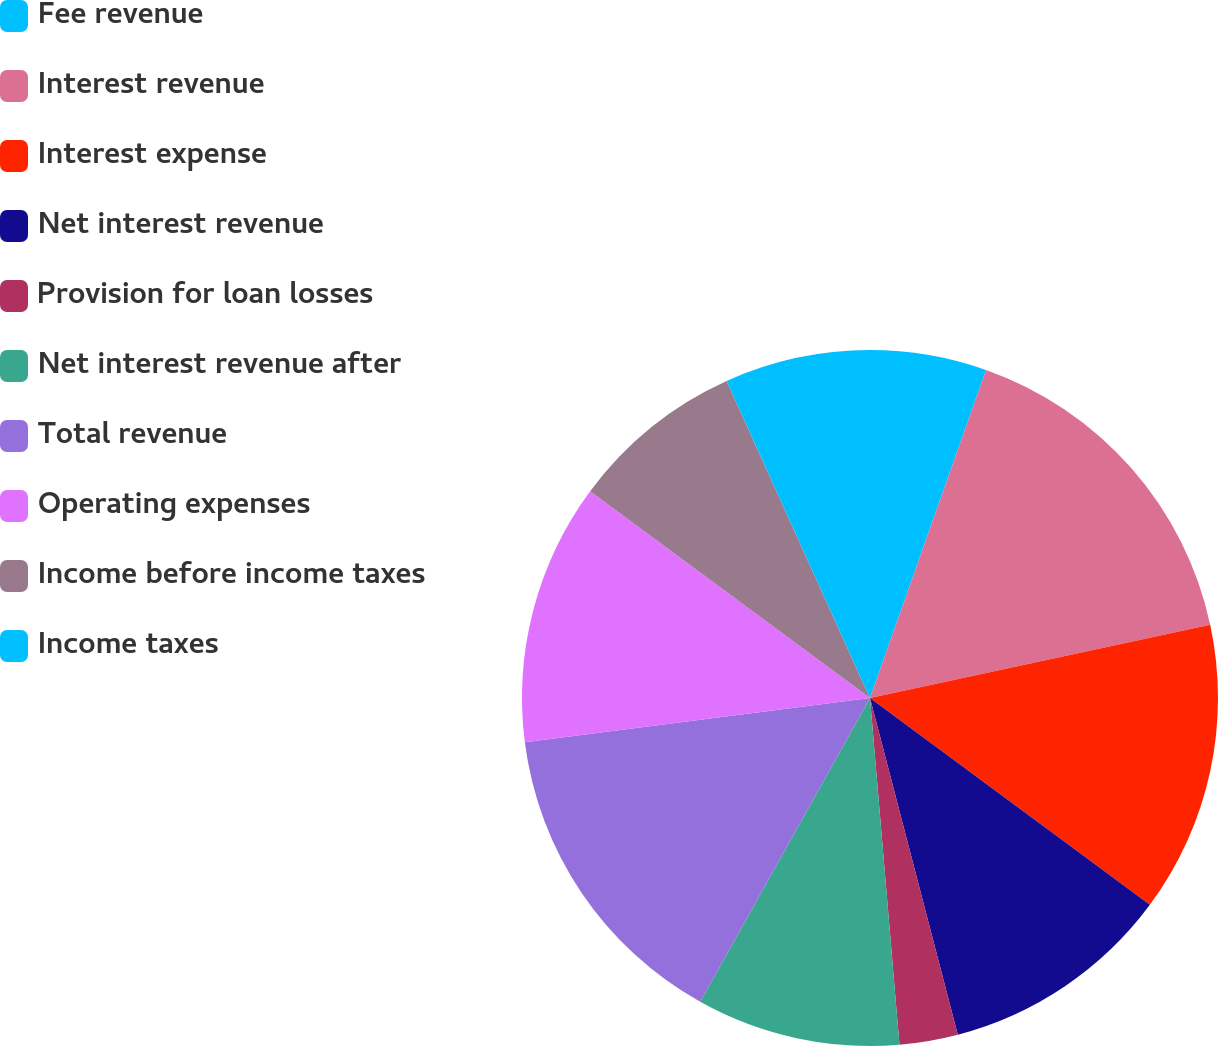Convert chart to OTSL. <chart><loc_0><loc_0><loc_500><loc_500><pie_chart><fcel>Fee revenue<fcel>Interest revenue<fcel>Interest expense<fcel>Net interest revenue<fcel>Provision for loan losses<fcel>Net interest revenue after<fcel>Total revenue<fcel>Operating expenses<fcel>Income before income taxes<fcel>Income taxes<nl><fcel>5.41%<fcel>16.21%<fcel>13.51%<fcel>10.81%<fcel>2.71%<fcel>9.46%<fcel>14.86%<fcel>12.16%<fcel>8.11%<fcel>6.76%<nl></chart> 